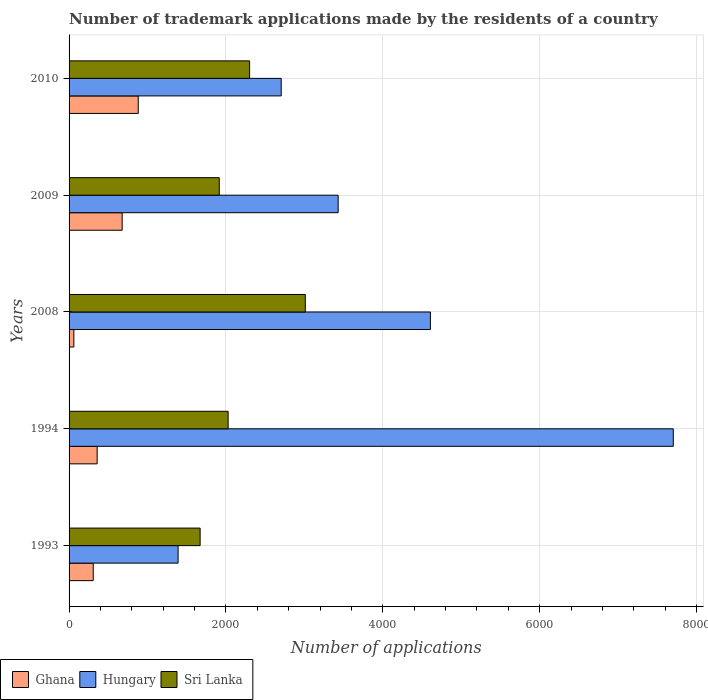How many different coloured bars are there?
Provide a succinct answer. 3. How many bars are there on the 1st tick from the bottom?
Ensure brevity in your answer.  3. What is the label of the 2nd group of bars from the top?
Make the answer very short. 2009. What is the number of trademark applications made by the residents in Ghana in 1994?
Offer a very short reply. 358. Across all years, what is the maximum number of trademark applications made by the residents in Sri Lanka?
Your answer should be very brief. 3012. Across all years, what is the minimum number of trademark applications made by the residents in Hungary?
Provide a succinct answer. 1390. In which year was the number of trademark applications made by the residents in Hungary maximum?
Your response must be concise. 1994. What is the total number of trademark applications made by the residents in Ghana in the graph?
Ensure brevity in your answer.  2286. What is the difference between the number of trademark applications made by the residents in Hungary in 1993 and that in 2008?
Ensure brevity in your answer.  -3217. What is the difference between the number of trademark applications made by the residents in Sri Lanka in 1994 and the number of trademark applications made by the residents in Ghana in 2009?
Provide a succinct answer. 1351. What is the average number of trademark applications made by the residents in Hungary per year?
Your answer should be compact. 3967.4. In the year 1993, what is the difference between the number of trademark applications made by the residents in Ghana and number of trademark applications made by the residents in Hungary?
Your response must be concise. -1082. What is the ratio of the number of trademark applications made by the residents in Hungary in 1993 to that in 1994?
Your answer should be very brief. 0.18. What is the difference between the highest and the second highest number of trademark applications made by the residents in Sri Lanka?
Provide a succinct answer. 710. What is the difference between the highest and the lowest number of trademark applications made by the residents in Hungary?
Give a very brief answer. 6314. In how many years, is the number of trademark applications made by the residents in Sri Lanka greater than the average number of trademark applications made by the residents in Sri Lanka taken over all years?
Ensure brevity in your answer.  2. Is it the case that in every year, the sum of the number of trademark applications made by the residents in Ghana and number of trademark applications made by the residents in Sri Lanka is greater than the number of trademark applications made by the residents in Hungary?
Your response must be concise. No. How many bars are there?
Ensure brevity in your answer.  15. Are all the bars in the graph horizontal?
Keep it short and to the point. Yes. Does the graph contain any zero values?
Keep it short and to the point. No. Does the graph contain grids?
Your answer should be compact. Yes. Where does the legend appear in the graph?
Ensure brevity in your answer.  Bottom left. How many legend labels are there?
Ensure brevity in your answer.  3. How are the legend labels stacked?
Keep it short and to the point. Horizontal. What is the title of the graph?
Give a very brief answer. Number of trademark applications made by the residents of a country. What is the label or title of the X-axis?
Your response must be concise. Number of applications. What is the Number of applications of Ghana in 1993?
Your answer should be compact. 308. What is the Number of applications of Hungary in 1993?
Keep it short and to the point. 1390. What is the Number of applications of Sri Lanka in 1993?
Your answer should be very brief. 1671. What is the Number of applications in Ghana in 1994?
Your answer should be very brief. 358. What is the Number of applications of Hungary in 1994?
Provide a short and direct response. 7704. What is the Number of applications in Sri Lanka in 1994?
Keep it short and to the point. 2028. What is the Number of applications of Ghana in 2008?
Provide a short and direct response. 61. What is the Number of applications in Hungary in 2008?
Provide a succinct answer. 4607. What is the Number of applications in Sri Lanka in 2008?
Make the answer very short. 3012. What is the Number of applications in Ghana in 2009?
Give a very brief answer. 677. What is the Number of applications of Hungary in 2009?
Your answer should be compact. 3431. What is the Number of applications of Sri Lanka in 2009?
Give a very brief answer. 1915. What is the Number of applications in Ghana in 2010?
Provide a succinct answer. 882. What is the Number of applications in Hungary in 2010?
Provide a short and direct response. 2705. What is the Number of applications of Sri Lanka in 2010?
Your response must be concise. 2302. Across all years, what is the maximum Number of applications in Ghana?
Make the answer very short. 882. Across all years, what is the maximum Number of applications of Hungary?
Your answer should be compact. 7704. Across all years, what is the maximum Number of applications in Sri Lanka?
Your answer should be very brief. 3012. Across all years, what is the minimum Number of applications of Hungary?
Your response must be concise. 1390. Across all years, what is the minimum Number of applications in Sri Lanka?
Make the answer very short. 1671. What is the total Number of applications in Ghana in the graph?
Keep it short and to the point. 2286. What is the total Number of applications in Hungary in the graph?
Your answer should be very brief. 1.98e+04. What is the total Number of applications in Sri Lanka in the graph?
Give a very brief answer. 1.09e+04. What is the difference between the Number of applications in Hungary in 1993 and that in 1994?
Make the answer very short. -6314. What is the difference between the Number of applications in Sri Lanka in 1993 and that in 1994?
Your answer should be compact. -357. What is the difference between the Number of applications in Ghana in 1993 and that in 2008?
Provide a short and direct response. 247. What is the difference between the Number of applications of Hungary in 1993 and that in 2008?
Make the answer very short. -3217. What is the difference between the Number of applications in Sri Lanka in 1993 and that in 2008?
Ensure brevity in your answer.  -1341. What is the difference between the Number of applications of Ghana in 1993 and that in 2009?
Provide a short and direct response. -369. What is the difference between the Number of applications of Hungary in 1993 and that in 2009?
Your answer should be very brief. -2041. What is the difference between the Number of applications of Sri Lanka in 1993 and that in 2009?
Your response must be concise. -244. What is the difference between the Number of applications of Ghana in 1993 and that in 2010?
Provide a succinct answer. -574. What is the difference between the Number of applications of Hungary in 1993 and that in 2010?
Your response must be concise. -1315. What is the difference between the Number of applications of Sri Lanka in 1993 and that in 2010?
Provide a short and direct response. -631. What is the difference between the Number of applications in Ghana in 1994 and that in 2008?
Your answer should be compact. 297. What is the difference between the Number of applications of Hungary in 1994 and that in 2008?
Your answer should be compact. 3097. What is the difference between the Number of applications in Sri Lanka in 1994 and that in 2008?
Give a very brief answer. -984. What is the difference between the Number of applications in Ghana in 1994 and that in 2009?
Offer a terse response. -319. What is the difference between the Number of applications of Hungary in 1994 and that in 2009?
Keep it short and to the point. 4273. What is the difference between the Number of applications of Sri Lanka in 1994 and that in 2009?
Keep it short and to the point. 113. What is the difference between the Number of applications in Ghana in 1994 and that in 2010?
Provide a succinct answer. -524. What is the difference between the Number of applications in Hungary in 1994 and that in 2010?
Provide a succinct answer. 4999. What is the difference between the Number of applications in Sri Lanka in 1994 and that in 2010?
Your response must be concise. -274. What is the difference between the Number of applications of Ghana in 2008 and that in 2009?
Your answer should be very brief. -616. What is the difference between the Number of applications of Hungary in 2008 and that in 2009?
Make the answer very short. 1176. What is the difference between the Number of applications in Sri Lanka in 2008 and that in 2009?
Offer a terse response. 1097. What is the difference between the Number of applications in Ghana in 2008 and that in 2010?
Give a very brief answer. -821. What is the difference between the Number of applications of Hungary in 2008 and that in 2010?
Keep it short and to the point. 1902. What is the difference between the Number of applications in Sri Lanka in 2008 and that in 2010?
Your answer should be very brief. 710. What is the difference between the Number of applications of Ghana in 2009 and that in 2010?
Ensure brevity in your answer.  -205. What is the difference between the Number of applications in Hungary in 2009 and that in 2010?
Your response must be concise. 726. What is the difference between the Number of applications of Sri Lanka in 2009 and that in 2010?
Provide a succinct answer. -387. What is the difference between the Number of applications in Ghana in 1993 and the Number of applications in Hungary in 1994?
Ensure brevity in your answer.  -7396. What is the difference between the Number of applications in Ghana in 1993 and the Number of applications in Sri Lanka in 1994?
Make the answer very short. -1720. What is the difference between the Number of applications of Hungary in 1993 and the Number of applications of Sri Lanka in 1994?
Provide a short and direct response. -638. What is the difference between the Number of applications of Ghana in 1993 and the Number of applications of Hungary in 2008?
Keep it short and to the point. -4299. What is the difference between the Number of applications in Ghana in 1993 and the Number of applications in Sri Lanka in 2008?
Offer a terse response. -2704. What is the difference between the Number of applications in Hungary in 1993 and the Number of applications in Sri Lanka in 2008?
Give a very brief answer. -1622. What is the difference between the Number of applications in Ghana in 1993 and the Number of applications in Hungary in 2009?
Offer a terse response. -3123. What is the difference between the Number of applications of Ghana in 1993 and the Number of applications of Sri Lanka in 2009?
Offer a terse response. -1607. What is the difference between the Number of applications of Hungary in 1993 and the Number of applications of Sri Lanka in 2009?
Keep it short and to the point. -525. What is the difference between the Number of applications of Ghana in 1993 and the Number of applications of Hungary in 2010?
Make the answer very short. -2397. What is the difference between the Number of applications of Ghana in 1993 and the Number of applications of Sri Lanka in 2010?
Your answer should be very brief. -1994. What is the difference between the Number of applications of Hungary in 1993 and the Number of applications of Sri Lanka in 2010?
Keep it short and to the point. -912. What is the difference between the Number of applications of Ghana in 1994 and the Number of applications of Hungary in 2008?
Give a very brief answer. -4249. What is the difference between the Number of applications in Ghana in 1994 and the Number of applications in Sri Lanka in 2008?
Offer a terse response. -2654. What is the difference between the Number of applications of Hungary in 1994 and the Number of applications of Sri Lanka in 2008?
Your answer should be compact. 4692. What is the difference between the Number of applications of Ghana in 1994 and the Number of applications of Hungary in 2009?
Your response must be concise. -3073. What is the difference between the Number of applications in Ghana in 1994 and the Number of applications in Sri Lanka in 2009?
Offer a very short reply. -1557. What is the difference between the Number of applications of Hungary in 1994 and the Number of applications of Sri Lanka in 2009?
Your answer should be compact. 5789. What is the difference between the Number of applications of Ghana in 1994 and the Number of applications of Hungary in 2010?
Ensure brevity in your answer.  -2347. What is the difference between the Number of applications in Ghana in 1994 and the Number of applications in Sri Lanka in 2010?
Ensure brevity in your answer.  -1944. What is the difference between the Number of applications of Hungary in 1994 and the Number of applications of Sri Lanka in 2010?
Provide a succinct answer. 5402. What is the difference between the Number of applications of Ghana in 2008 and the Number of applications of Hungary in 2009?
Offer a terse response. -3370. What is the difference between the Number of applications of Ghana in 2008 and the Number of applications of Sri Lanka in 2009?
Your response must be concise. -1854. What is the difference between the Number of applications of Hungary in 2008 and the Number of applications of Sri Lanka in 2009?
Your answer should be compact. 2692. What is the difference between the Number of applications of Ghana in 2008 and the Number of applications of Hungary in 2010?
Keep it short and to the point. -2644. What is the difference between the Number of applications of Ghana in 2008 and the Number of applications of Sri Lanka in 2010?
Offer a very short reply. -2241. What is the difference between the Number of applications of Hungary in 2008 and the Number of applications of Sri Lanka in 2010?
Provide a succinct answer. 2305. What is the difference between the Number of applications of Ghana in 2009 and the Number of applications of Hungary in 2010?
Offer a very short reply. -2028. What is the difference between the Number of applications of Ghana in 2009 and the Number of applications of Sri Lanka in 2010?
Make the answer very short. -1625. What is the difference between the Number of applications in Hungary in 2009 and the Number of applications in Sri Lanka in 2010?
Ensure brevity in your answer.  1129. What is the average Number of applications in Ghana per year?
Your response must be concise. 457.2. What is the average Number of applications in Hungary per year?
Keep it short and to the point. 3967.4. What is the average Number of applications of Sri Lanka per year?
Keep it short and to the point. 2185.6. In the year 1993, what is the difference between the Number of applications of Ghana and Number of applications of Hungary?
Your answer should be very brief. -1082. In the year 1993, what is the difference between the Number of applications of Ghana and Number of applications of Sri Lanka?
Give a very brief answer. -1363. In the year 1993, what is the difference between the Number of applications of Hungary and Number of applications of Sri Lanka?
Offer a very short reply. -281. In the year 1994, what is the difference between the Number of applications in Ghana and Number of applications in Hungary?
Give a very brief answer. -7346. In the year 1994, what is the difference between the Number of applications of Ghana and Number of applications of Sri Lanka?
Offer a very short reply. -1670. In the year 1994, what is the difference between the Number of applications in Hungary and Number of applications in Sri Lanka?
Provide a short and direct response. 5676. In the year 2008, what is the difference between the Number of applications of Ghana and Number of applications of Hungary?
Keep it short and to the point. -4546. In the year 2008, what is the difference between the Number of applications in Ghana and Number of applications in Sri Lanka?
Your response must be concise. -2951. In the year 2008, what is the difference between the Number of applications of Hungary and Number of applications of Sri Lanka?
Provide a short and direct response. 1595. In the year 2009, what is the difference between the Number of applications in Ghana and Number of applications in Hungary?
Offer a very short reply. -2754. In the year 2009, what is the difference between the Number of applications in Ghana and Number of applications in Sri Lanka?
Make the answer very short. -1238. In the year 2009, what is the difference between the Number of applications in Hungary and Number of applications in Sri Lanka?
Keep it short and to the point. 1516. In the year 2010, what is the difference between the Number of applications in Ghana and Number of applications in Hungary?
Your response must be concise. -1823. In the year 2010, what is the difference between the Number of applications of Ghana and Number of applications of Sri Lanka?
Your answer should be compact. -1420. In the year 2010, what is the difference between the Number of applications in Hungary and Number of applications in Sri Lanka?
Give a very brief answer. 403. What is the ratio of the Number of applications in Ghana in 1993 to that in 1994?
Provide a succinct answer. 0.86. What is the ratio of the Number of applications of Hungary in 1993 to that in 1994?
Offer a very short reply. 0.18. What is the ratio of the Number of applications in Sri Lanka in 1993 to that in 1994?
Your response must be concise. 0.82. What is the ratio of the Number of applications in Ghana in 1993 to that in 2008?
Offer a very short reply. 5.05. What is the ratio of the Number of applications of Hungary in 1993 to that in 2008?
Your answer should be compact. 0.3. What is the ratio of the Number of applications of Sri Lanka in 1993 to that in 2008?
Offer a very short reply. 0.55. What is the ratio of the Number of applications of Ghana in 1993 to that in 2009?
Your response must be concise. 0.45. What is the ratio of the Number of applications of Hungary in 1993 to that in 2009?
Provide a short and direct response. 0.41. What is the ratio of the Number of applications in Sri Lanka in 1993 to that in 2009?
Your response must be concise. 0.87. What is the ratio of the Number of applications in Ghana in 1993 to that in 2010?
Your answer should be compact. 0.35. What is the ratio of the Number of applications of Hungary in 1993 to that in 2010?
Offer a very short reply. 0.51. What is the ratio of the Number of applications of Sri Lanka in 1993 to that in 2010?
Offer a terse response. 0.73. What is the ratio of the Number of applications of Ghana in 1994 to that in 2008?
Provide a succinct answer. 5.87. What is the ratio of the Number of applications in Hungary in 1994 to that in 2008?
Your response must be concise. 1.67. What is the ratio of the Number of applications in Sri Lanka in 1994 to that in 2008?
Give a very brief answer. 0.67. What is the ratio of the Number of applications in Ghana in 1994 to that in 2009?
Your answer should be very brief. 0.53. What is the ratio of the Number of applications of Hungary in 1994 to that in 2009?
Your answer should be compact. 2.25. What is the ratio of the Number of applications in Sri Lanka in 1994 to that in 2009?
Give a very brief answer. 1.06. What is the ratio of the Number of applications of Ghana in 1994 to that in 2010?
Give a very brief answer. 0.41. What is the ratio of the Number of applications in Hungary in 1994 to that in 2010?
Ensure brevity in your answer.  2.85. What is the ratio of the Number of applications of Sri Lanka in 1994 to that in 2010?
Ensure brevity in your answer.  0.88. What is the ratio of the Number of applications in Ghana in 2008 to that in 2009?
Provide a short and direct response. 0.09. What is the ratio of the Number of applications of Hungary in 2008 to that in 2009?
Offer a very short reply. 1.34. What is the ratio of the Number of applications in Sri Lanka in 2008 to that in 2009?
Provide a short and direct response. 1.57. What is the ratio of the Number of applications in Ghana in 2008 to that in 2010?
Your response must be concise. 0.07. What is the ratio of the Number of applications of Hungary in 2008 to that in 2010?
Provide a short and direct response. 1.7. What is the ratio of the Number of applications in Sri Lanka in 2008 to that in 2010?
Your answer should be very brief. 1.31. What is the ratio of the Number of applications of Ghana in 2009 to that in 2010?
Your response must be concise. 0.77. What is the ratio of the Number of applications of Hungary in 2009 to that in 2010?
Your answer should be very brief. 1.27. What is the ratio of the Number of applications in Sri Lanka in 2009 to that in 2010?
Give a very brief answer. 0.83. What is the difference between the highest and the second highest Number of applications in Ghana?
Your answer should be very brief. 205. What is the difference between the highest and the second highest Number of applications in Hungary?
Provide a short and direct response. 3097. What is the difference between the highest and the second highest Number of applications in Sri Lanka?
Your answer should be very brief. 710. What is the difference between the highest and the lowest Number of applications of Ghana?
Offer a terse response. 821. What is the difference between the highest and the lowest Number of applications of Hungary?
Provide a short and direct response. 6314. What is the difference between the highest and the lowest Number of applications in Sri Lanka?
Give a very brief answer. 1341. 